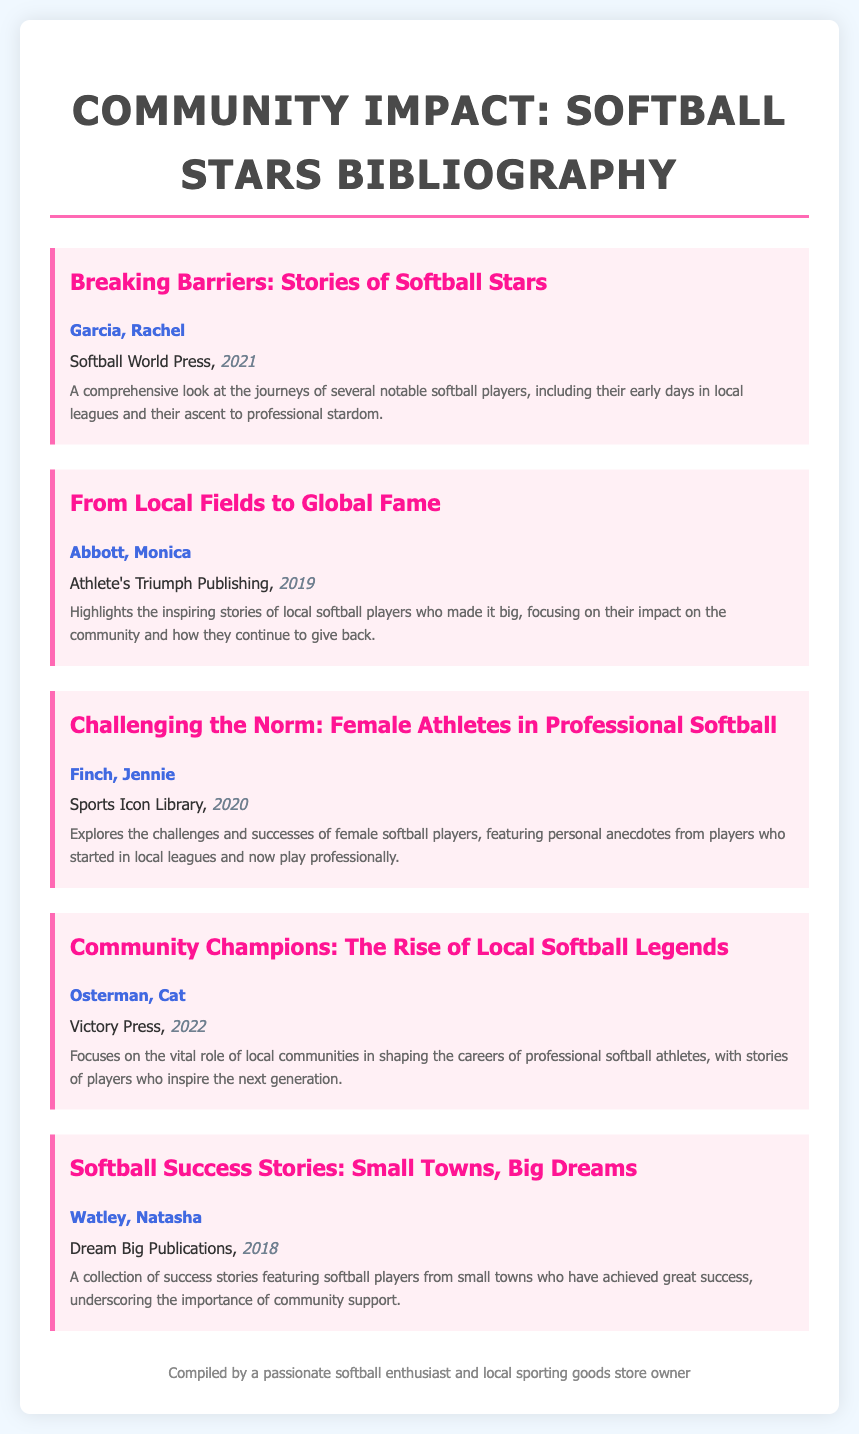what is the title of the first bibliography item? The title of the first bibliography item is found at the beginning of the item, which is "Breaking Barriers: Stories of Softball Stars."
Answer: Breaking Barriers: Stories of Softball Stars who is the author of "From Local Fields to Global Fame"? The author is identified right after the title in the second bibliography item, which is Monica Abbott.
Answer: Monica Abbott what year was "Challenging the Norm: Female Athletes in Professional Softball" published? The year of publication is included at the end of the bibliography item, which shows it was published in 2020.
Answer: 2020 how many bibliography items are listed in the document? To determine this, we count all the separate bibliography entries, which totals to five.
Answer: 5 which publication focuses on community impact? This can be inferred from the description of the bibliography items, particularly "Community Champions: The Rise of Local Softball Legends" as it directly addresses the role of local communities.
Answer: Community Champions: The Rise of Local Softball Legends who published "Softball Success Stories: Small Towns, Big Dreams"? The publisher is noted under the title in the bibliography item, which is Dream Big Publications.
Answer: Dream Big Publications what is the main theme of the bibliography? The overall theme relates to the impact of local players in their communities and their journey to professional success, as described in multiple entries.
Answer: Community impact and success stories which item was published most recently? This can be determined by comparing the years mentioned in the bibliography items, with the latest being "Community Champions: The Rise of Local Softball Legends" from 2022.
Answer: Community Champions: The Rise of Local Softball Legends 